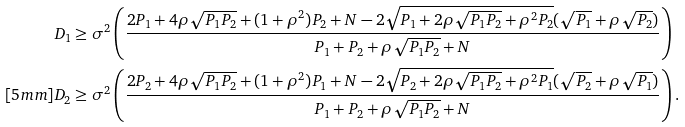<formula> <loc_0><loc_0><loc_500><loc_500>D _ { 1 } & \geq \sigma ^ { 2 } \left ( \frac { 2 P _ { 1 } + 4 \rho \sqrt { P _ { 1 } P _ { 2 } } + ( 1 + \rho ^ { 2 } ) P _ { 2 } + N - 2 \sqrt { P _ { 1 } + 2 \rho \sqrt { P _ { 1 } P _ { 2 } } + \rho ^ { 2 } P _ { 2 } } ( \sqrt { P _ { 1 } } + \rho \sqrt { P _ { 2 } } ) } { P _ { 1 } + P _ { 2 } + \rho \sqrt { P _ { 1 } P _ { 2 } } + N } \right ) \\ [ 5 m m ] D _ { 2 } & \geq \sigma ^ { 2 } \left ( \frac { 2 P _ { 2 } + 4 \rho \sqrt { P _ { 1 } P _ { 2 } } + ( 1 + \rho ^ { 2 } ) P _ { 1 } + N - 2 \sqrt { P _ { 2 } + 2 \rho \sqrt { P _ { 1 } P _ { 2 } } + \rho ^ { 2 } P _ { 1 } } ( \sqrt { P _ { 2 } } + \rho \sqrt { P _ { 1 } } ) } { P _ { 1 } + P _ { 2 } + \rho \sqrt { P _ { 1 } P _ { 2 } } + N } \right ) .</formula> 